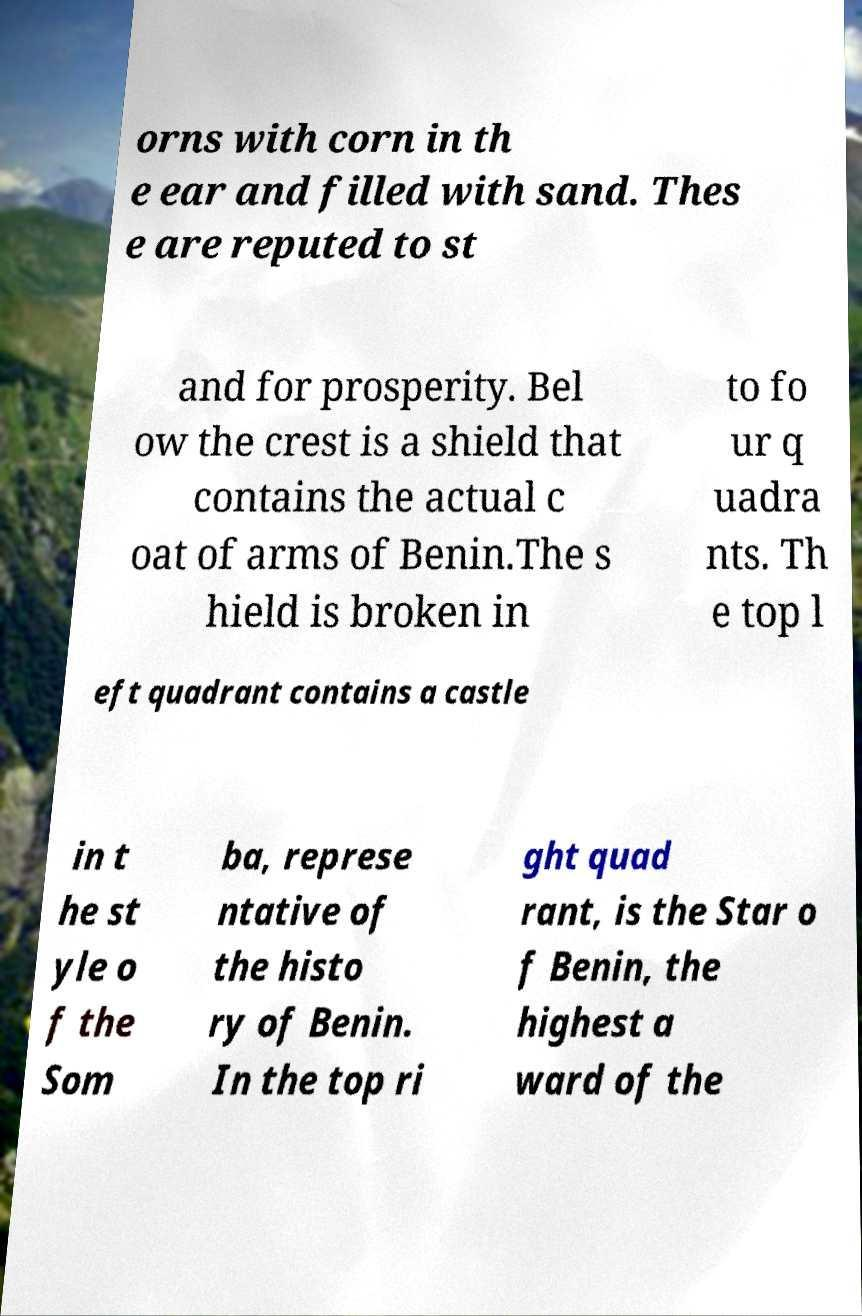Could you assist in decoding the text presented in this image and type it out clearly? orns with corn in th e ear and filled with sand. Thes e are reputed to st and for prosperity. Bel ow the crest is a shield that contains the actual c oat of arms of Benin.The s hield is broken in to fo ur q uadra nts. Th e top l eft quadrant contains a castle in t he st yle o f the Som ba, represe ntative of the histo ry of Benin. In the top ri ght quad rant, is the Star o f Benin, the highest a ward of the 